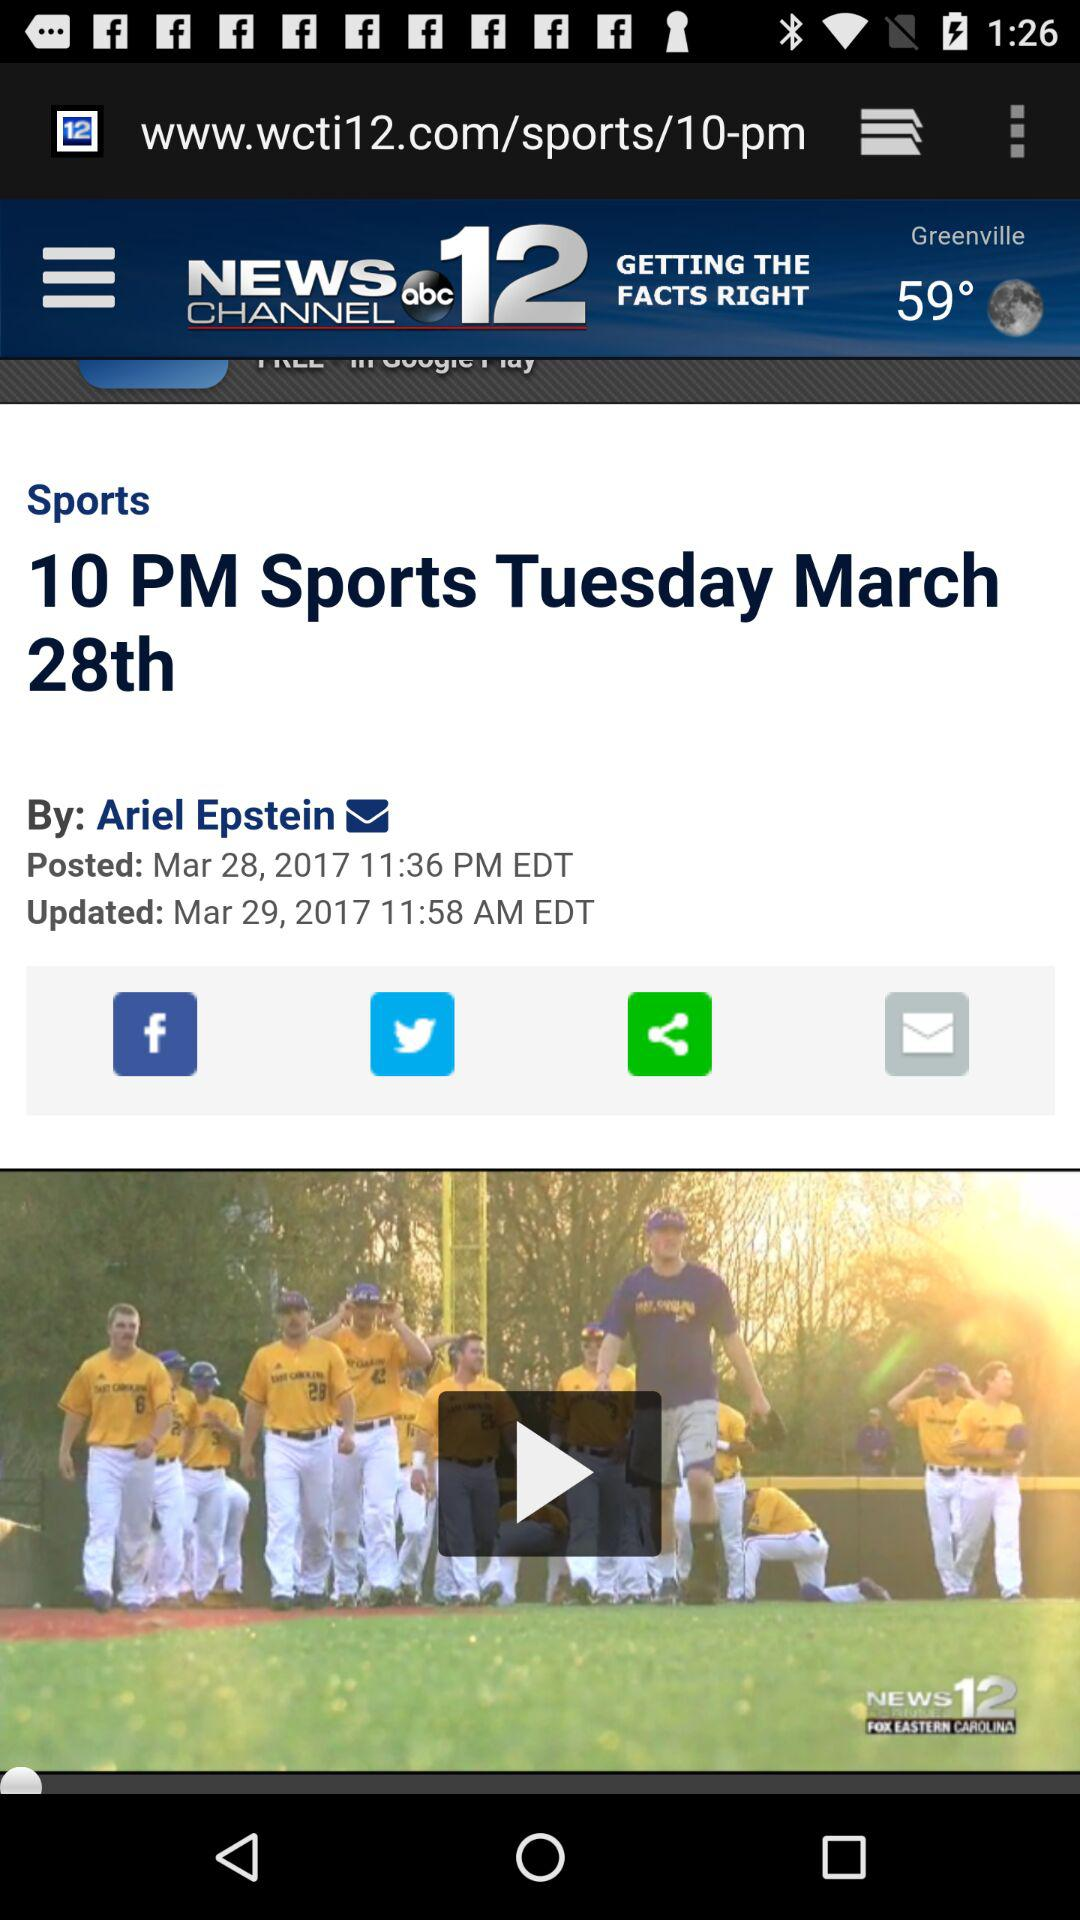What is the name of the application? The name of the application is "WCTI News Channel 12". 